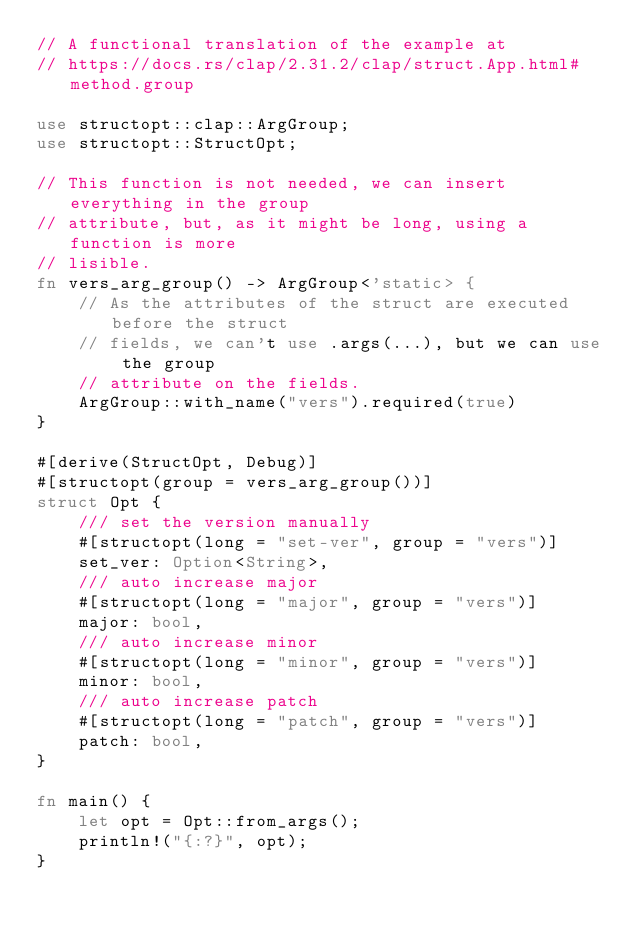Convert code to text. <code><loc_0><loc_0><loc_500><loc_500><_Rust_>// A functional translation of the example at
// https://docs.rs/clap/2.31.2/clap/struct.App.html#method.group

use structopt::clap::ArgGroup;
use structopt::StructOpt;

// This function is not needed, we can insert everything in the group
// attribute, but, as it might be long, using a function is more
// lisible.
fn vers_arg_group() -> ArgGroup<'static> {
    // As the attributes of the struct are executed before the struct
    // fields, we can't use .args(...), but we can use the group
    // attribute on the fields.
    ArgGroup::with_name("vers").required(true)
}

#[derive(StructOpt, Debug)]
#[structopt(group = vers_arg_group())]
struct Opt {
    /// set the version manually
    #[structopt(long = "set-ver", group = "vers")]
    set_ver: Option<String>,
    /// auto increase major
    #[structopt(long = "major", group = "vers")]
    major: bool,
    /// auto increase minor
    #[structopt(long = "minor", group = "vers")]
    minor: bool,
    /// auto increase patch
    #[structopt(long = "patch", group = "vers")]
    patch: bool,
}

fn main() {
    let opt = Opt::from_args();
    println!("{:?}", opt);
}
</code> 